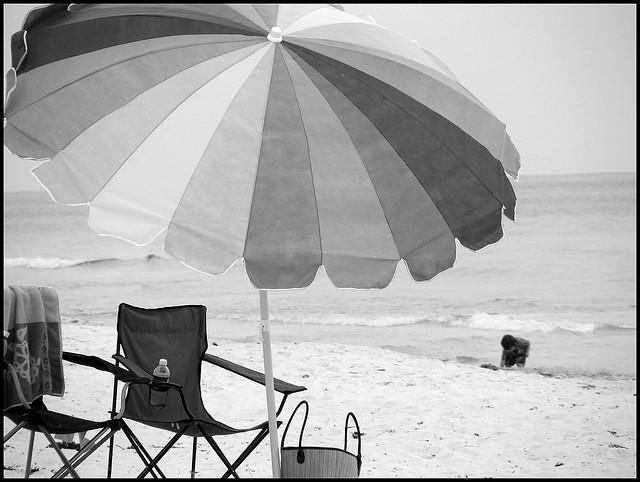Is the umbrella different colors?
Short answer required. Yes. Where is the plastic water bottle?
Quick response, please. On chair. How many panels on the umbrella?
Quick response, please. 20. What color is that umbrella and why is it important?
Keep it brief. Black and white. What is the umbrella on?
Concise answer only. Beach. What is the kid doing?
Concise answer only. Digging. 